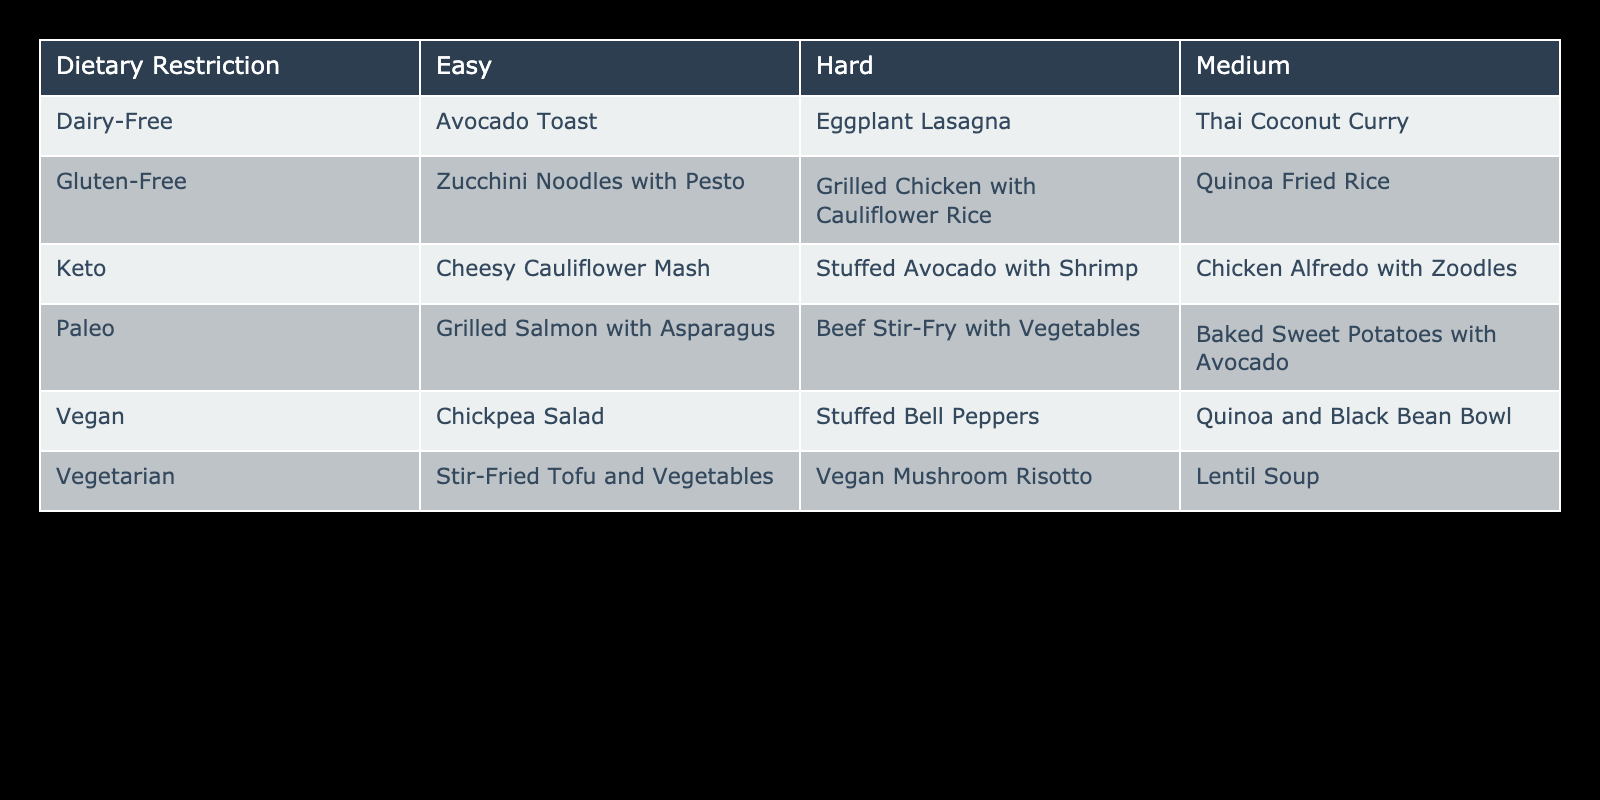What is the easiest gluten-free meal option? The easiest meal option for gluten-free is in the "Easy" column under "Gluten-Free." That meal is "Zucchini Noodles with Pesto."
Answer: Zucchini Noodles with Pesto How many vegan meals are categorized as hard? To find this, look at the "Vegan" row and count the meals in the "Hard" column. There is one meal listed, "Stuffed Bell Peppers."
Answer: 1 Which dietary restriction has the most easy meal options? By checking the "Easy" column for each dietary restriction, we find that "Vegan," "Vegetarian," "Gluten-Free," "Paleo," "Keto," and "Dairy-Free" each have one easy meal. Therefore, no single dietary restriction has more than one meal in the easy category.
Answer: None Do vegetarian meals include any hard options? The "Vegetarian" row can be examined for the "Hard" column. It lists "Vegan Mushroom Risotto," confirming that vegetarian meals do include a hard option.
Answer: Yes What is the difference in the number of easy meals between vegan and paleo diets? Both the "Vegan" and "Paleo" rows have one easy meal. The difference in the number of easy meals between the two diets is 1 - 1 = 0.
Answer: 0 Which cooking difficulty level has the least number of options overall? First, check the total number of meals in each cooking difficulty level. There are four "Easy" meals, three "Medium" meals, and three "Hard" meals. Thus, the "Medium" and "Hard" levels share the least number of options, which is three meals each.
Answer: Medium and Hard Is there a meal that is both dairy-free and easy? Looking at the "Dairy-Free" row under the "Easy" column, "Avocado Toast" is found, indicating there is an easy meal that is dairy-free.
Answer: Yes What is the total number of hard meals available for keto and paleo diets combined? Counting the "Hard" meals in the "Keto" and "Paleo" rows, there is one "Stuffed Avocado with Shrimp" for Keto and one "Beef Stir-Fry with Vegetables" for Paleo. The total count is 1 + 1 = 2.
Answer: 2 